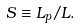Convert formula to latex. <formula><loc_0><loc_0><loc_500><loc_500>S \equiv L _ { p } / L .</formula> 